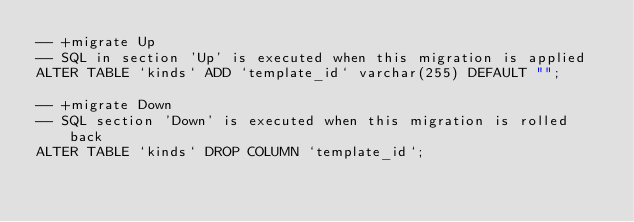<code> <loc_0><loc_0><loc_500><loc_500><_SQL_>-- +migrate Up
-- SQL in section 'Up' is executed when this migration is applied
ALTER TABLE `kinds` ADD `template_id` varchar(255) DEFAULT "";

-- +migrate Down
-- SQL section 'Down' is executed when this migration is rolled back
ALTER TABLE `kinds` DROP COLUMN `template_id`;
</code> 